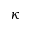Convert formula to latex. <formula><loc_0><loc_0><loc_500><loc_500>\kappa</formula> 